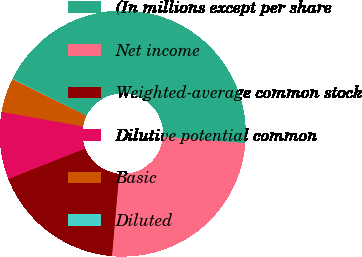<chart> <loc_0><loc_0><loc_500><loc_500><pie_chart><fcel>(In millions except per share<fcel>Net income<fcel>Weighted-average common stock<fcel>Dilutive potential common<fcel>Basic<fcel>Diluted<nl><fcel>43.88%<fcel>25.16%<fcel>17.6%<fcel>8.84%<fcel>4.46%<fcel>0.08%<nl></chart> 